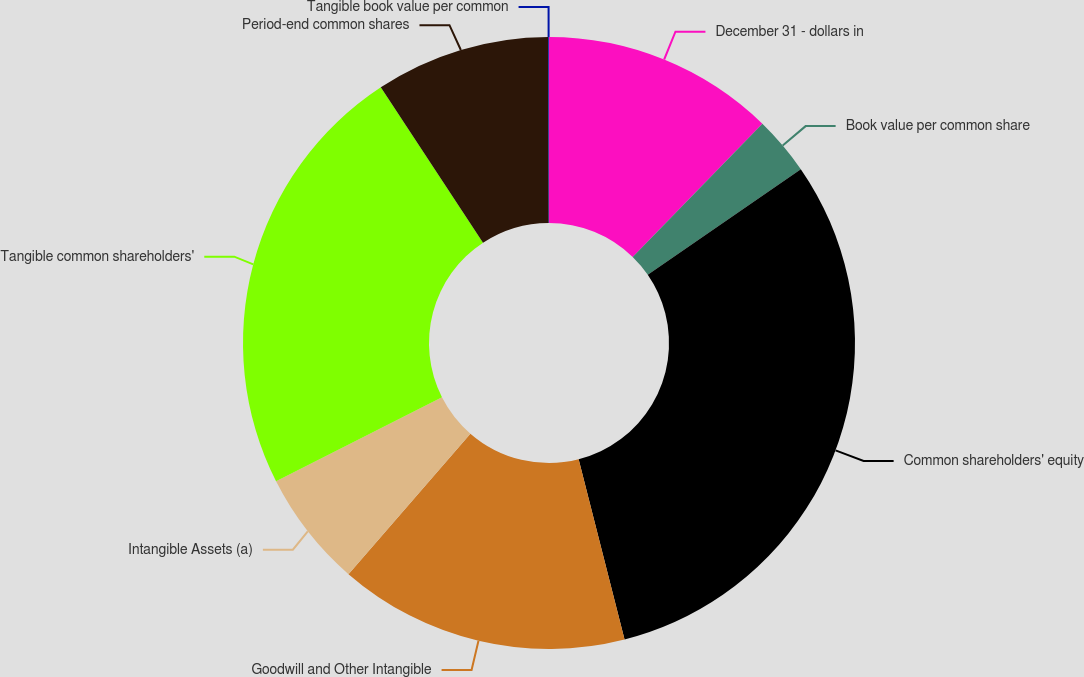Convert chart. <chart><loc_0><loc_0><loc_500><loc_500><pie_chart><fcel>December 31 - dollars in<fcel>Book value per common share<fcel>Common shareholders' equity<fcel>Goodwill and Other Intangible<fcel>Intangible Assets (a)<fcel>Tangible common shareholders'<fcel>Period-end common shares<fcel>Tangible book value per common<nl><fcel>12.28%<fcel>3.1%<fcel>30.64%<fcel>15.34%<fcel>6.16%<fcel>23.2%<fcel>9.22%<fcel>0.04%<nl></chart> 